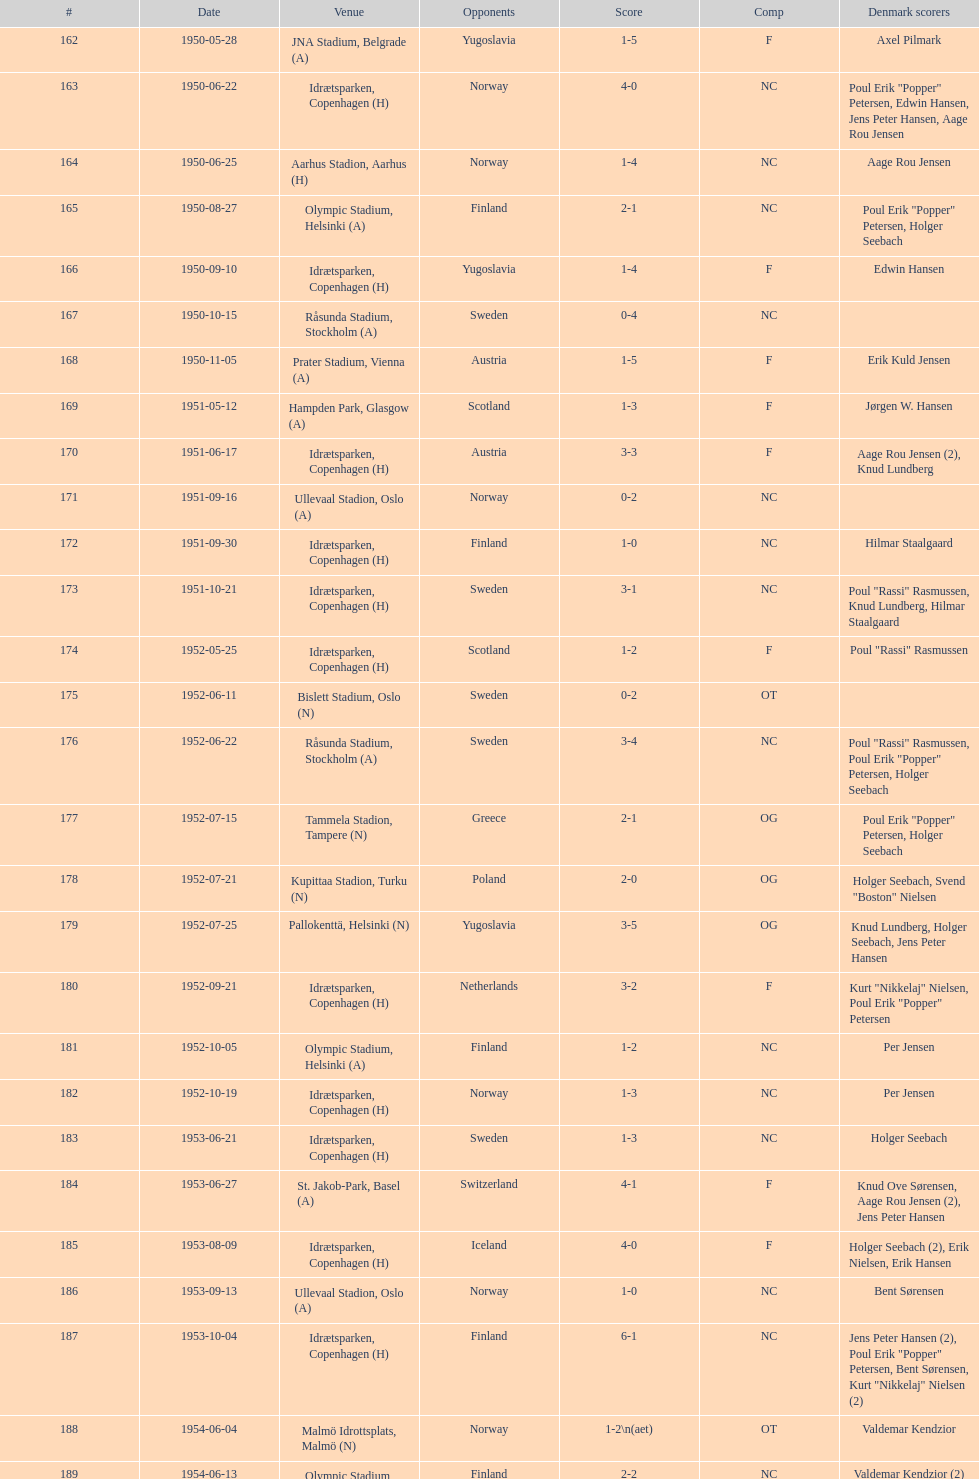Who did they play in the game listed directly above july 25, 1952? Poland. 